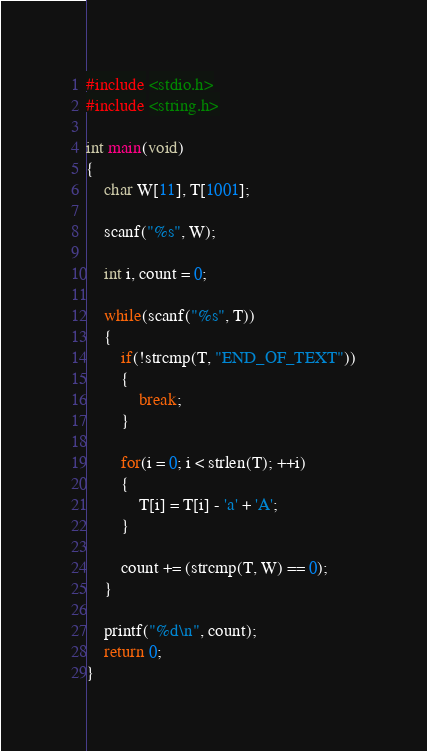<code> <loc_0><loc_0><loc_500><loc_500><_C_>#include <stdio.h>
#include <string.h>

int main(void)
{
    char W[11], T[1001];

    scanf("%s", W);

    int i, count = 0;

    while(scanf("%s", T))
    {
        if(!strcmp(T, "END_OF_TEXT"))
        {
            break;
        }

        for(i = 0; i < strlen(T); ++i)
        {
            T[i] = T[i] - 'a' + 'A';
        }

        count += (strcmp(T, W) == 0);
    }

    printf("%d\n", count);
    return 0;
}</code> 